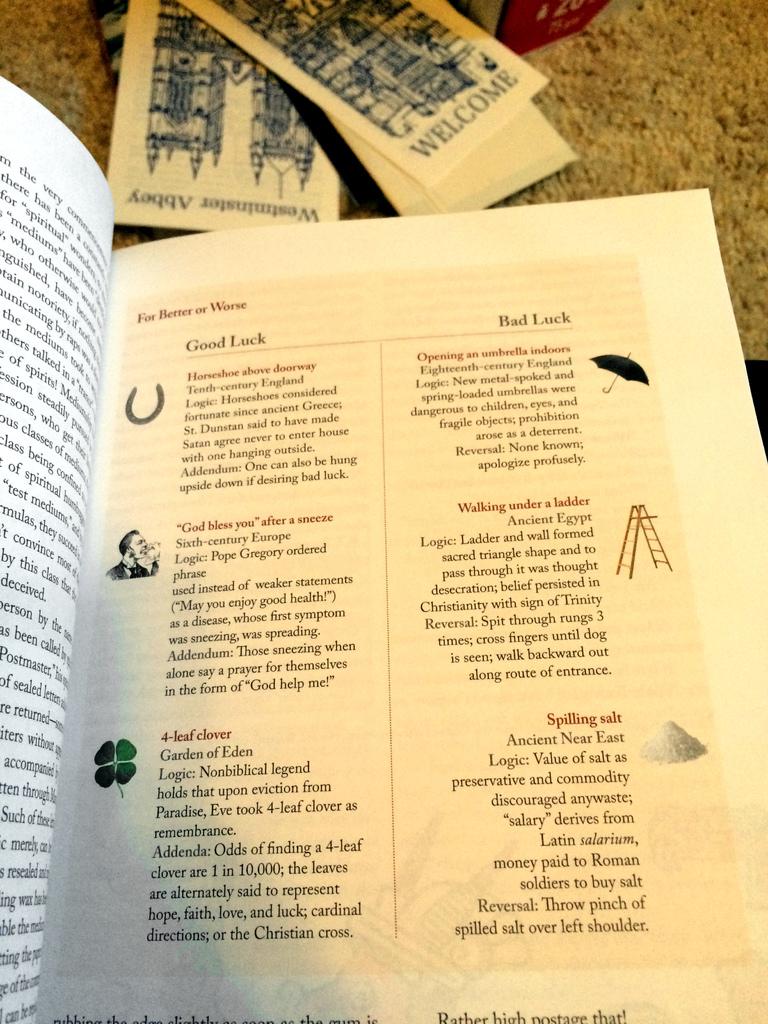What is the title of the book?
Make the answer very short. For better or worse. What is the title at the top left corner of the page?
Offer a terse response. For better or worse. 